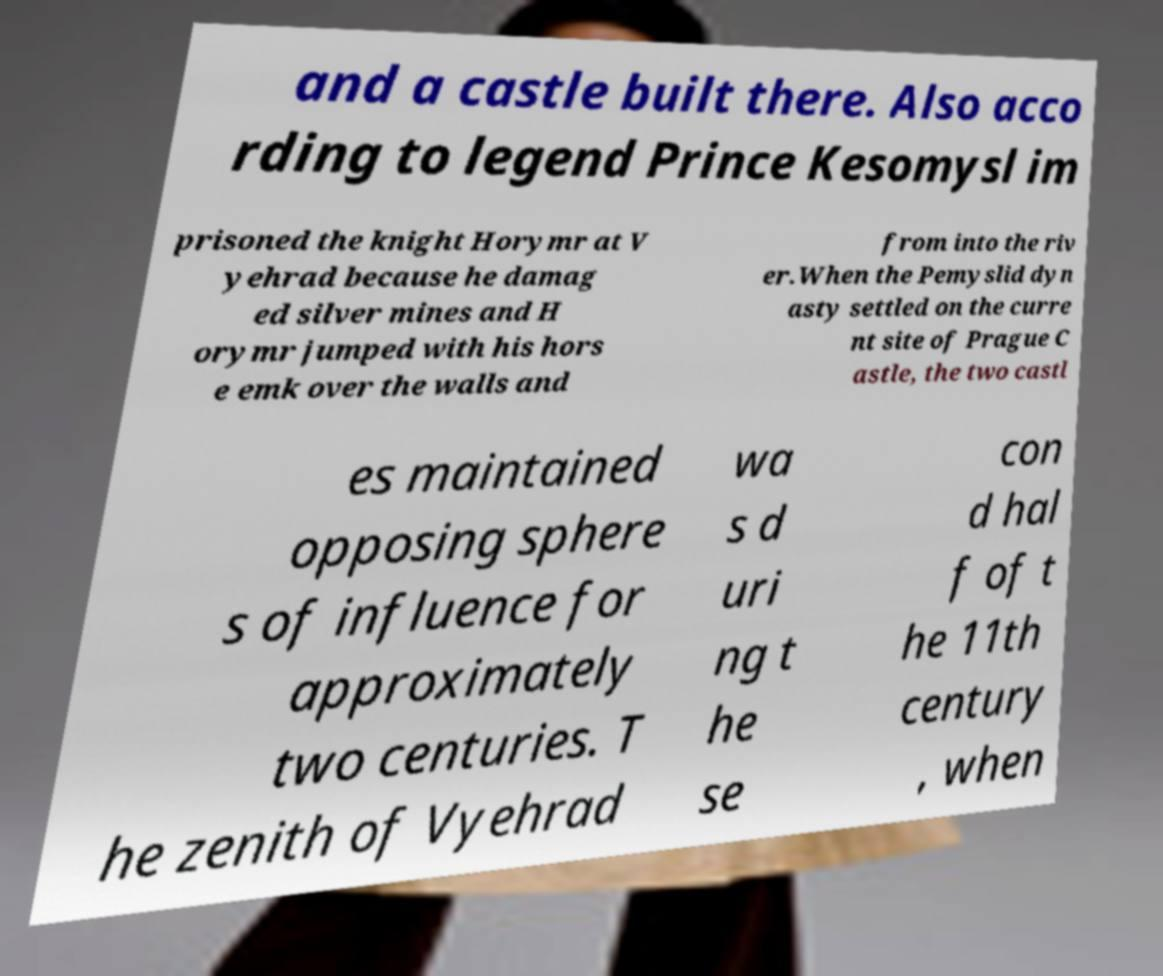Please identify and transcribe the text found in this image. and a castle built there. Also acco rding to legend Prince Kesomysl im prisoned the knight Horymr at V yehrad because he damag ed silver mines and H orymr jumped with his hors e emk over the walls and from into the riv er.When the Pemyslid dyn asty settled on the curre nt site of Prague C astle, the two castl es maintained opposing sphere s of influence for approximately two centuries. T he zenith of Vyehrad wa s d uri ng t he se con d hal f of t he 11th century , when 